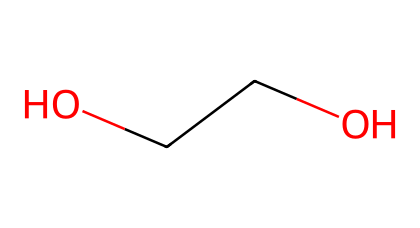What is the chemical name of this compound? The SMILES representation C(CO)O indicates the presence of two carbon atoms (C) and a hydroxyl group (OH), which is characteristic of ethylene glycol. Therefore, the chemical name is based on its structure.
Answer: ethylene glycol How many carbon atoms are in this molecule? By analyzing the SMILES representation, we can see there are two 'C' characters, signifying two carbon atoms in the structure.
Answer: 2 How many oxygen atoms are present in this chemical? The SMILES notation indicates two 'O' characters in the structure, indicating the presence of two oxygen atoms linked to the carbon structure.
Answer: 2 What functional groups are present in this molecule? The structure includes hydroxyl groups (-OH), which are characteristic of alcohols, hence the functional group present is an alcohol.
Answer: alcohol What is the primary use of this compound in hydroponics? Ethylene glycol, owing to its properties, is commonly used as an antifreeze agent in hydroponic systems to prevent the liquid from freezing in colder temperatures.
Answer: antifreeze Why is ethylene glycol preferred over other substances in hydroponic systems? Ethylene glycol has favorable physical properties such as low freezing point and high solubility in water, making it suitable for maintaining optimal temperatures in nutrient solutions.
Answer: favorable properties 